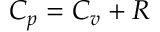<formula> <loc_0><loc_0><loc_500><loc_500>C _ { p } = C _ { v } + R</formula> 